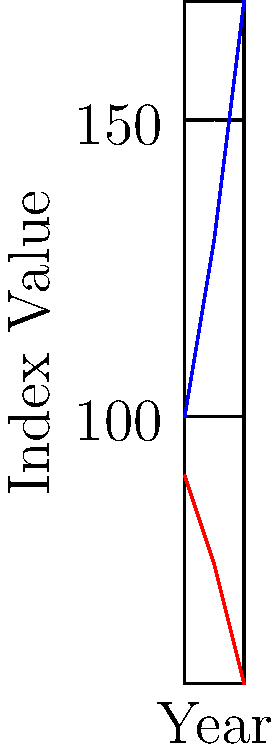Based on the time-series data shown in the graph, calculate the rate of change in the Dark Sky Index between 2010 and 2020. How does this correlate with the growth in Urban Area? To solve this problem, we'll follow these steps:

1. Calculate the rate of change for the Dark Sky Index:
   a. Dark Sky Index in 2010: 90
   b. Dark Sky Index in 2020: 55
   c. Total change: 90 - 55 = 35 (decrease)
   d. Time period: 2020 - 2010 = 10 years
   e. Rate of change = 35 / 10 = 3.5 units per year (decrease)

2. Calculate the rate of change for Urban Area:
   a. Urban Area in 2010: 100
   b. Urban Area in 2020: 170
   c. Total change: 170 - 100 = 70 (increase)
   d. Time period: 10 years
   e. Rate of change = 70 / 10 = 7 units per year (increase)

3. Analyze the correlation:
   As the Urban Area increases by 7 units per year, the Dark Sky Index decreases by 3.5 units per year. This shows a strong negative correlation between urban growth and dark sky preservation.

4. Calculate the correlation coefficient:
   To quantify the relationship, we can use the Pearson correlation coefficient:
   
   $$r = \frac{\sum_{i=1}^{n} (x_i - \bar{x})(y_i - \bar{y})}{\sqrt{\sum_{i=1}^{n} (x_i - \bar{x})^2} \sqrt{\sum_{i=1}^{n} (y_i - \bar{y})^2}}$$

   Where $x$ represents Urban Area and $y$ represents Dark Sky Index.

   Calculating this yields $r \approx -0.9986$, indicating a very strong negative correlation.
Answer: Dark Sky Index decreases by 3.5 units/year; strong negative correlation (r ≈ -0.9986) with Urban Area growth. 